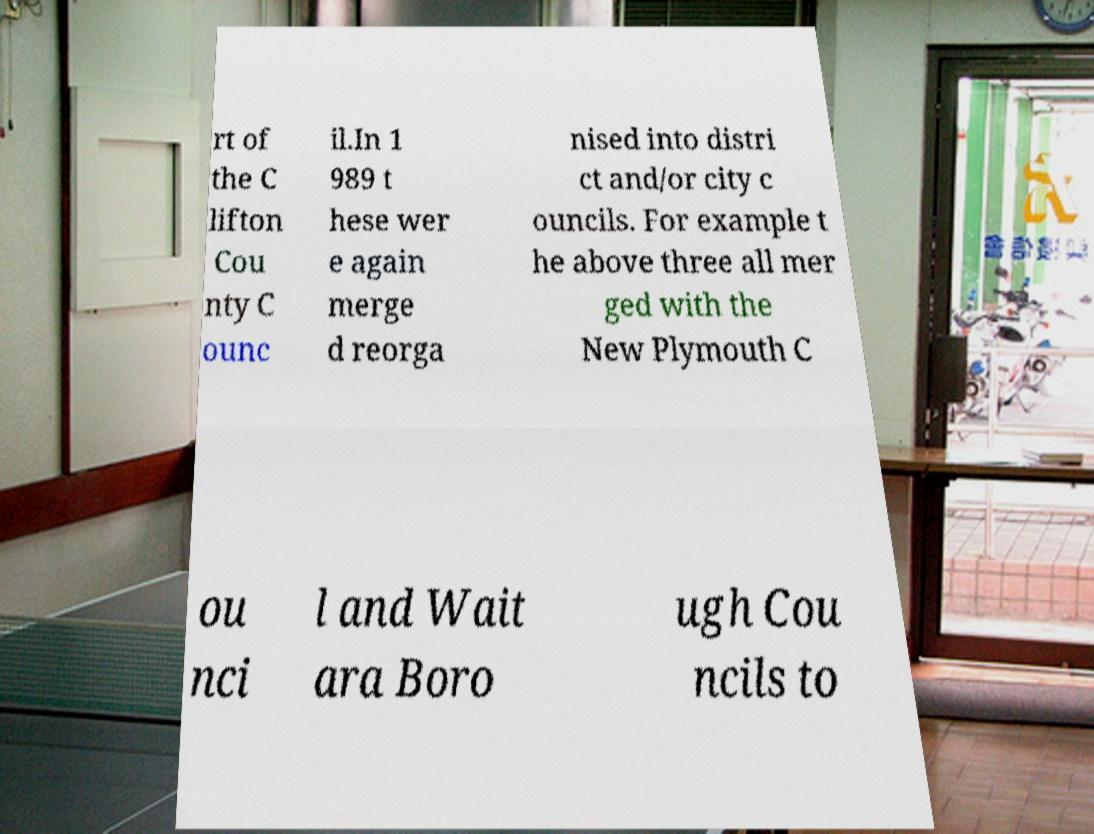Could you extract and type out the text from this image? rt of the C lifton Cou nty C ounc il.In 1 989 t hese wer e again merge d reorga nised into distri ct and/or city c ouncils. For example t he above three all mer ged with the New Plymouth C ou nci l and Wait ara Boro ugh Cou ncils to 